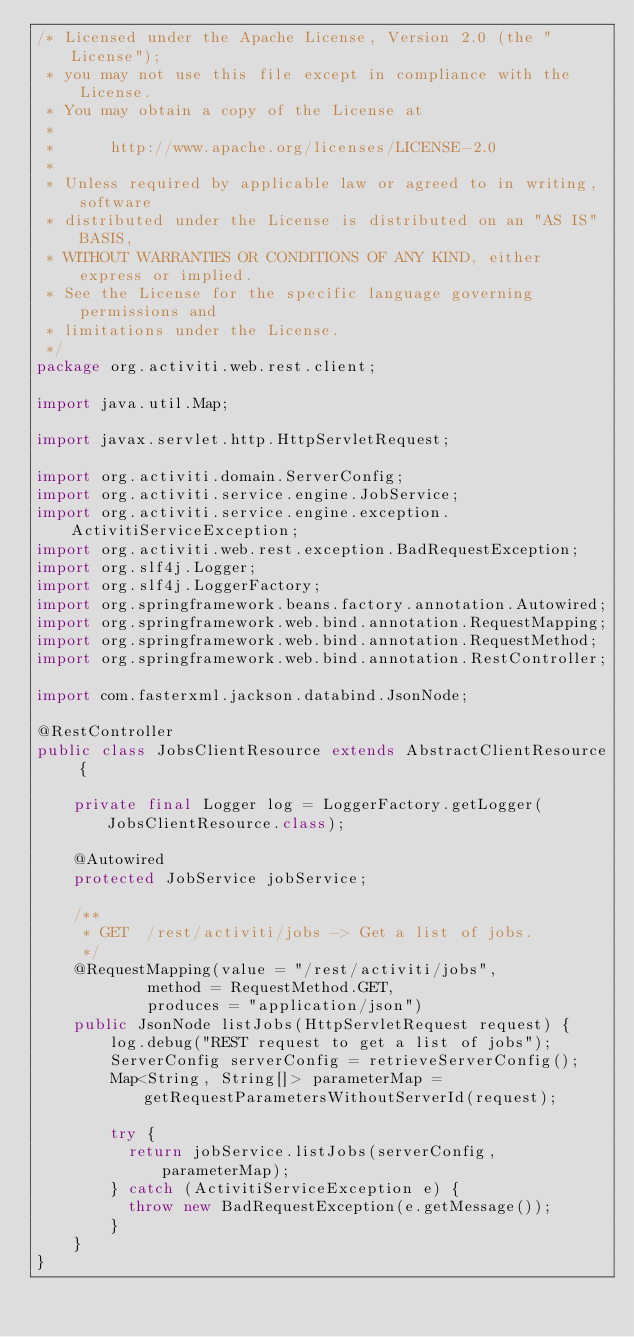<code> <loc_0><loc_0><loc_500><loc_500><_Java_>/* Licensed under the Apache License, Version 2.0 (the "License");
 * you may not use this file except in compliance with the License.
 * You may obtain a copy of the License at
 *
 *      http://www.apache.org/licenses/LICENSE-2.0
 *
 * Unless required by applicable law or agreed to in writing, software
 * distributed under the License is distributed on an "AS IS" BASIS,
 * WITHOUT WARRANTIES OR CONDITIONS OF ANY KIND, either express or implied.
 * See the License for the specific language governing permissions and
 * limitations under the License.
 */
package org.activiti.web.rest.client;

import java.util.Map;

import javax.servlet.http.HttpServletRequest;

import org.activiti.domain.ServerConfig;
import org.activiti.service.engine.JobService;
import org.activiti.service.engine.exception.ActivitiServiceException;
import org.activiti.web.rest.exception.BadRequestException;
import org.slf4j.Logger;
import org.slf4j.LoggerFactory;
import org.springframework.beans.factory.annotation.Autowired;
import org.springframework.web.bind.annotation.RequestMapping;
import org.springframework.web.bind.annotation.RequestMethod;
import org.springframework.web.bind.annotation.RestController;

import com.fasterxml.jackson.databind.JsonNode;

@RestController
public class JobsClientResource extends AbstractClientResource {

    private final Logger log = LoggerFactory.getLogger(JobsClientResource.class);
    
    @Autowired
    protected JobService jobService;

    /**
     * GET  /rest/activiti/jobs -> Get a list of jobs.
     */
    @RequestMapping(value = "/rest/activiti/jobs",
            method = RequestMethod.GET,
            produces = "application/json")
    public JsonNode listJobs(HttpServletRequest request) {
        log.debug("REST request to get a list of jobs");
        ServerConfig serverConfig = retrieveServerConfig();
        Map<String, String[]> parameterMap = getRequestParametersWithoutServerId(request);
        
        try {
	        return jobService.listJobs(serverConfig, parameterMap);
        } catch (ActivitiServiceException e) {
        	throw new BadRequestException(e.getMessage());
        }
    }
}
</code> 